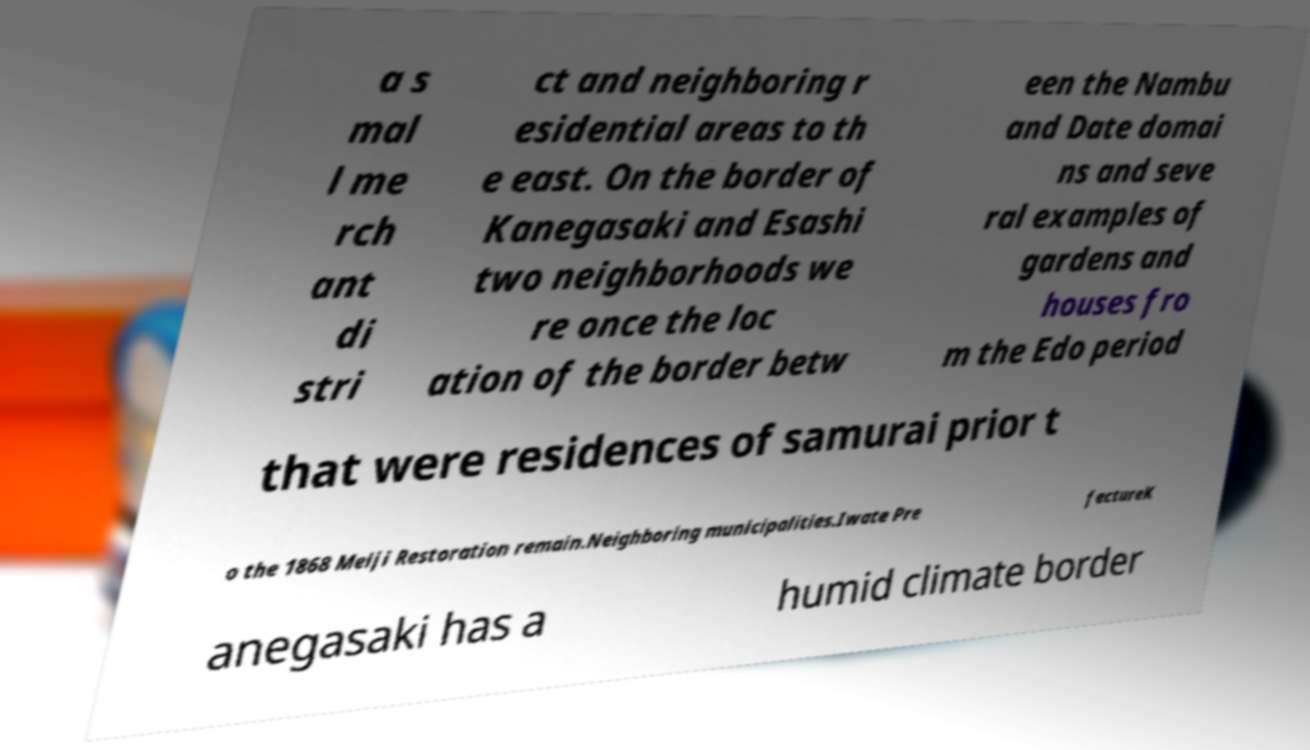For documentation purposes, I need the text within this image transcribed. Could you provide that? a s mal l me rch ant di stri ct and neighboring r esidential areas to th e east. On the border of Kanegasaki and Esashi two neighborhoods we re once the loc ation of the border betw een the Nambu and Date domai ns and seve ral examples of gardens and houses fro m the Edo period that were residences of samurai prior t o the 1868 Meiji Restoration remain.Neighboring municipalities.Iwate Pre fectureK anegasaki has a humid climate border 